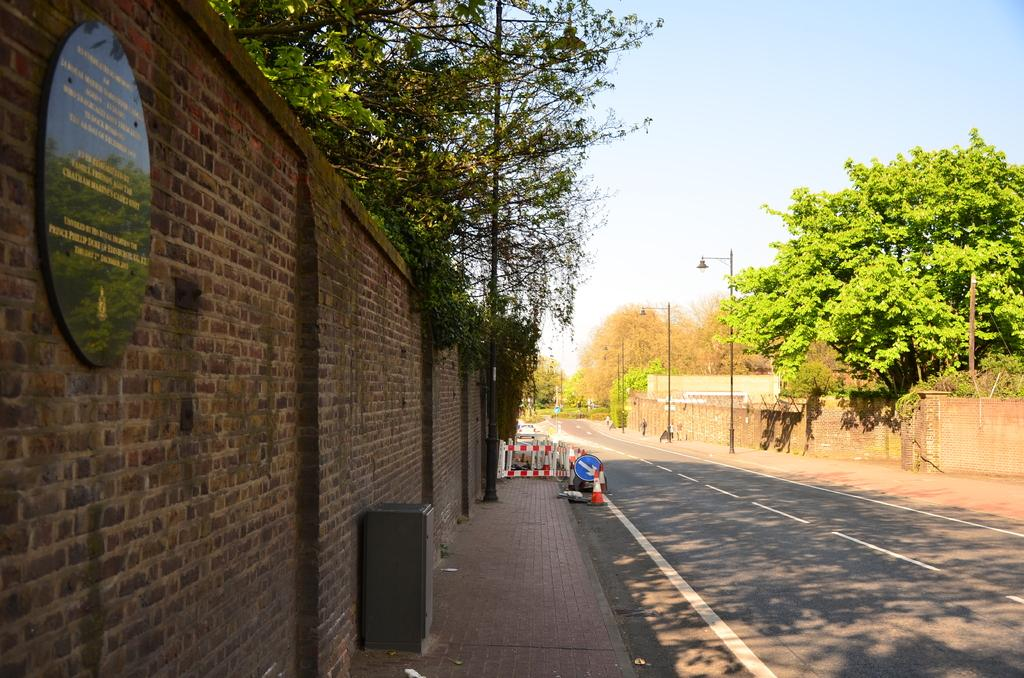What type of structure can be seen in the image? There is a wall in the image. What is hanging on the wall in the image? A: There is a banner in the image. What type of vegetation is visible in the image? There are trees in the image. What type of lighting is present in the image? There are street lamps in the image. What can be seen in the background of the image? The sky is visible in the image. How does the banner balance itself on the wall in the image? The banner does not need to balance itself on the wall; it is likely attached or hung securely. What story is being told by the trees in the image? There is no story being told by the trees in the image; they are simply a part of the natural environment. 